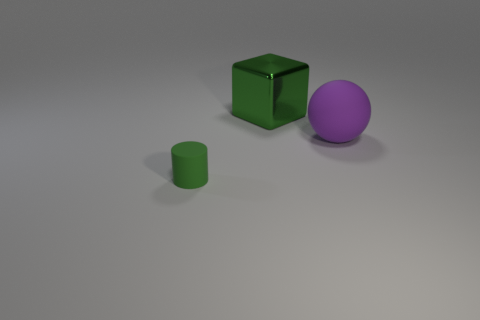What is the shape of the green object that is the same size as the purple sphere?
Offer a very short reply. Cube. What number of other objects are there of the same shape as the tiny green thing?
Give a very brief answer. 0. Do the green block and the matte thing that is on the left side of the big purple thing have the same size?
Your answer should be very brief. No. What number of things are either things behind the small green matte cylinder or cylinders?
Offer a very short reply. 3. What is the shape of the matte object that is in front of the big purple object?
Provide a succinct answer. Cylinder. Are there an equal number of small things left of the cylinder and rubber objects that are behind the block?
Your response must be concise. Yes. The object that is left of the big matte sphere and behind the small thing is what color?
Keep it short and to the point. Green. There is a green thing that is in front of the rubber object that is to the right of the large metal block; what is its material?
Offer a very short reply. Rubber. Is the size of the metal cube the same as the sphere?
Keep it short and to the point. Yes. How many small things are rubber spheres or gray metallic cylinders?
Ensure brevity in your answer.  0. 